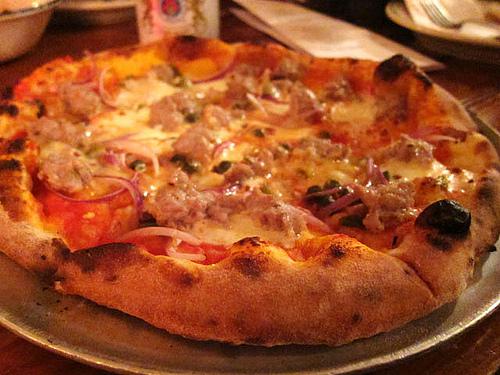Does this item contain yeast?
Concise answer only. Yes. What is this food?
Be succinct. Pizza. Has this food been cooked?
Short answer required. Yes. What are the black things on this pizza?
Short answer required. Olives. 